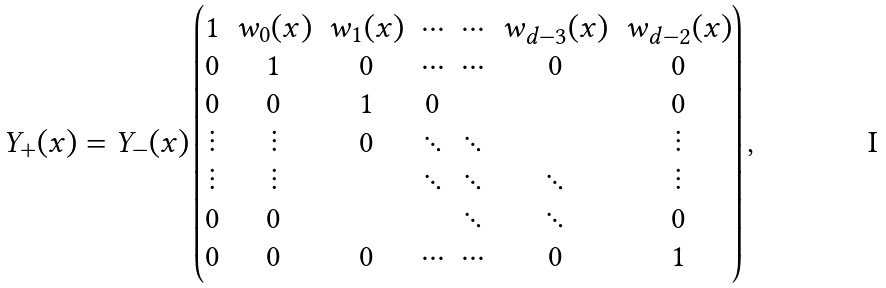<formula> <loc_0><loc_0><loc_500><loc_500>Y _ { + } ( x ) = Y _ { - } ( x ) \begin{pmatrix} 1 & w _ { 0 } ( x ) & w _ { 1 } ( x ) & \cdots & \cdots & w _ { d - 3 } ( x ) & w _ { d - 2 } ( x ) \\ 0 & 1 & 0 & \cdots & \cdots & 0 & 0 \\ 0 & 0 & 1 & 0 & & & 0 \\ \vdots & \vdots & 0 & \ddots & \ddots & & \vdots \\ \vdots & \vdots & & \ddots & \ddots & \ddots & \vdots \\ 0 & 0 & & & \ddots & \ddots & 0 \\ 0 & 0 & 0 & \cdots & \cdots & 0 & 1 \end{pmatrix} ,</formula> 